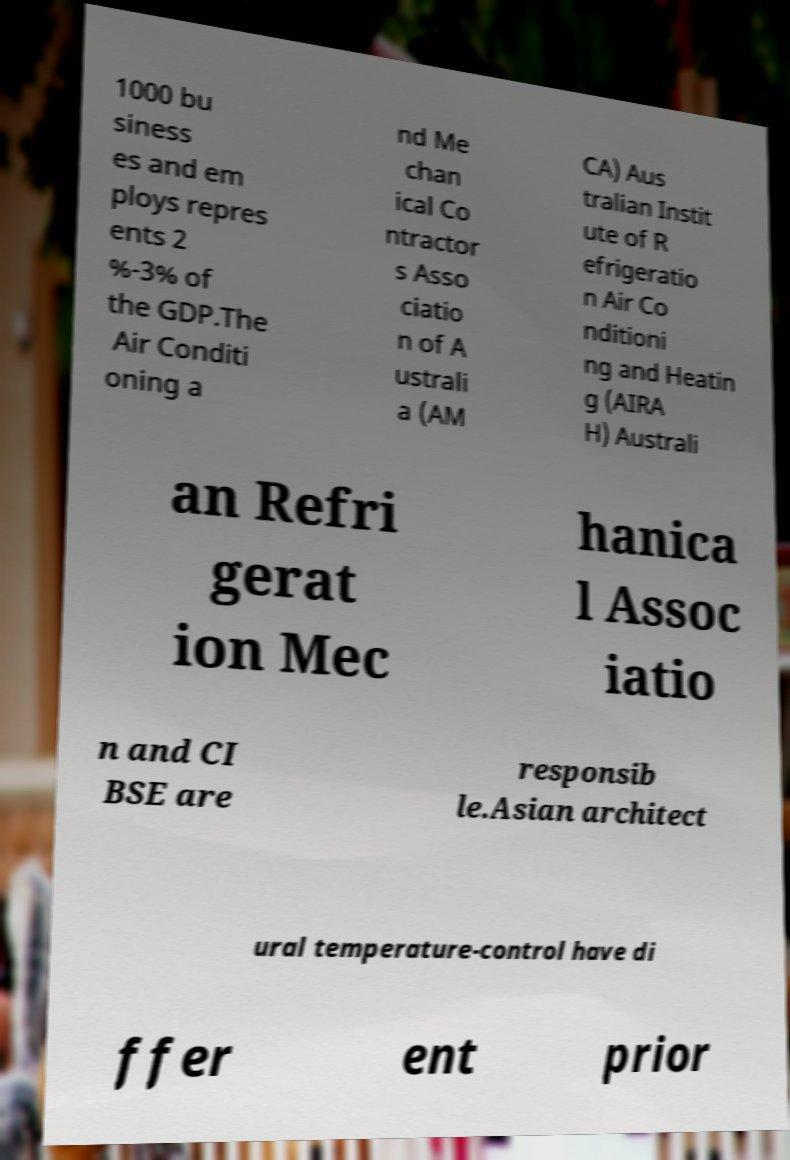Can you read and provide the text displayed in the image?This photo seems to have some interesting text. Can you extract and type it out for me? 1000 bu siness es and em ploys repres ents 2 %-3% of the GDP.The Air Conditi oning a nd Me chan ical Co ntractor s Asso ciatio n of A ustrali a (AM CA) Aus tralian Instit ute of R efrigeratio n Air Co nditioni ng and Heatin g (AIRA H) Australi an Refri gerat ion Mec hanica l Assoc iatio n and CI BSE are responsib le.Asian architect ural temperature-control have di ffer ent prior 